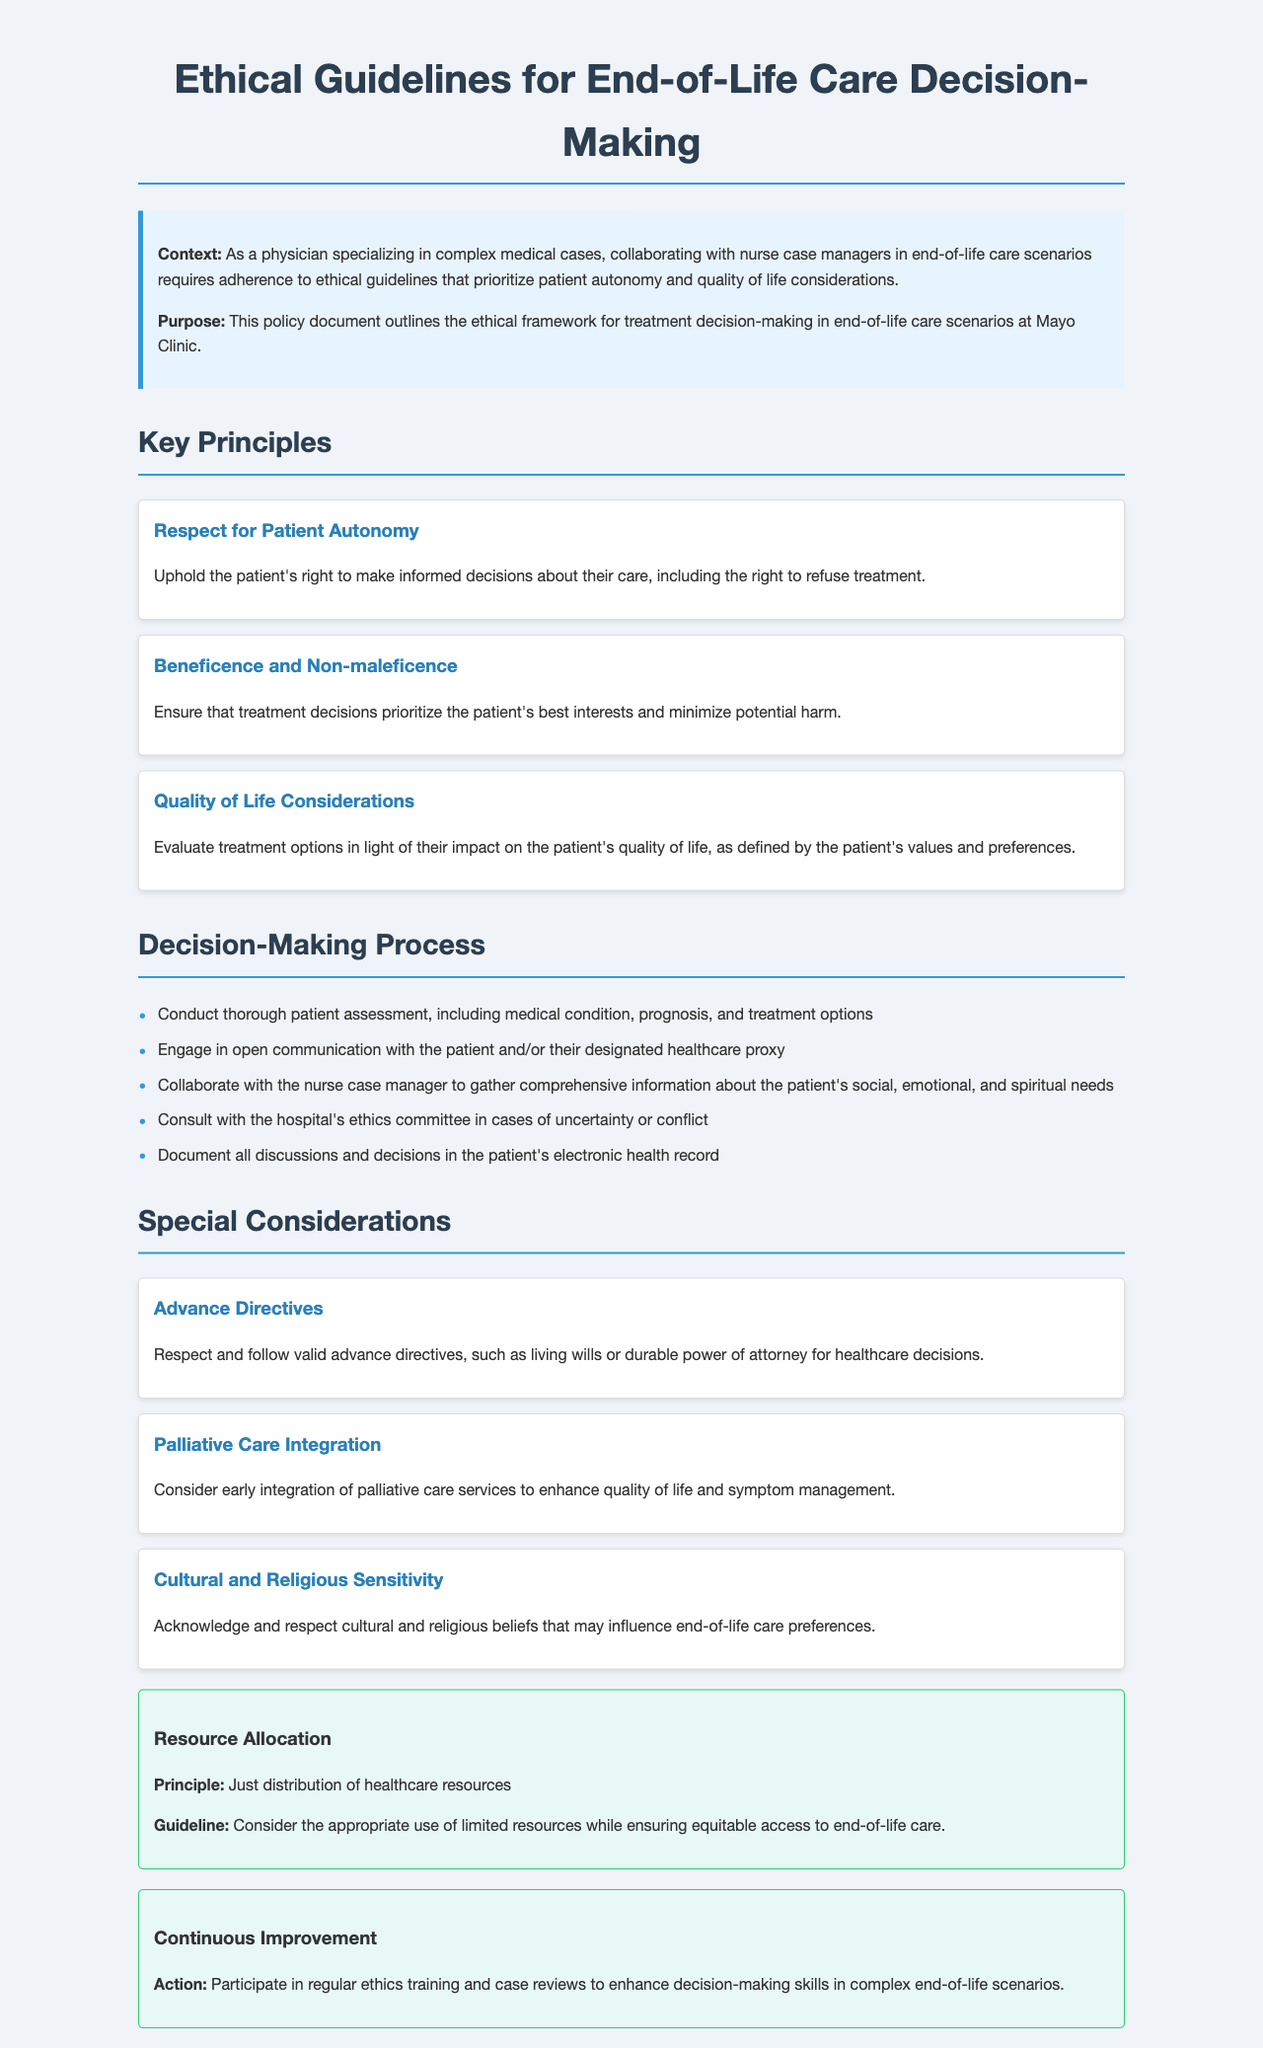What is the title of the document? The title is specified at the top of the document and indicates the main topic covered in it.
Answer: Ethical Guidelines for End-of-Life Care Decision-Making What principle emphasizes minimizing potential harm? This principle is listed under the key principles and focuses on ensuring patient safety and well-being.
Answer: Beneficence and Non-maleficence What is the recommended action for patients' advance directives? This consideration outlines the expectations for honoring patients' pre-established choices regarding medical treatment.
Answer: Respect and follow valid advance directives What should be documented after discussions and decisions? This is a crucial process step mentioned to ensure accountability and record-keeping in treatment decision-making.
Answer: Document all discussions and decisions Which committee should be consulted in cases of uncertainty? This committee is mentioned as a resource for resolving conflicts related to treatment decisions.
Answer: Ethics committee What is the focus of the principle on resource allocation? This principle outlines the importance of fairness in distributing healthcare resources in end-of-life care situations.
Answer: Just distribution of healthcare resources 